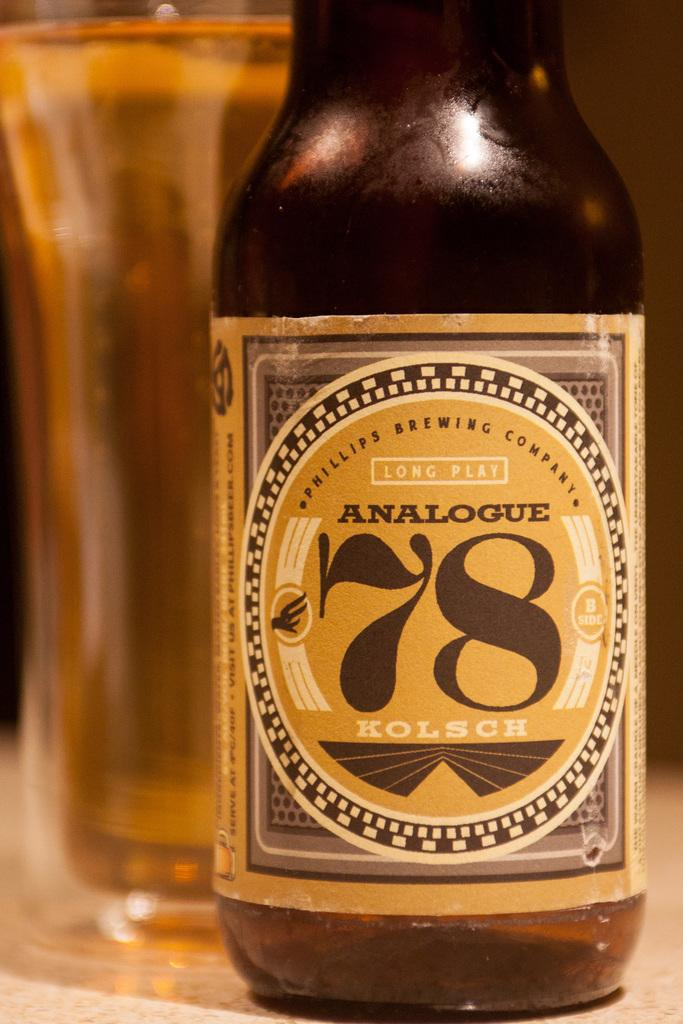<image>
Share a concise interpretation of the image provided. A bottle of long plat Analogue 78 beverage 